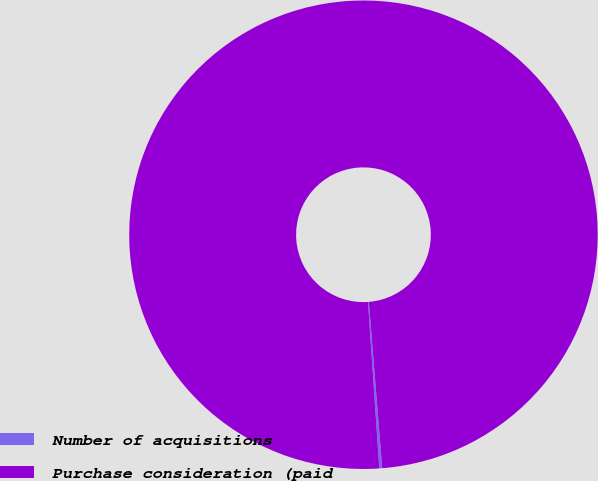<chart> <loc_0><loc_0><loc_500><loc_500><pie_chart><fcel>Number of acquisitions<fcel>Purchase consideration (paid<nl><fcel>0.2%<fcel>99.8%<nl></chart> 